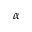<formula> <loc_0><loc_0><loc_500><loc_500>\alpha</formula> 